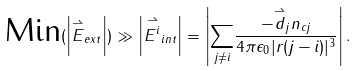<formula> <loc_0><loc_0><loc_500><loc_500>\text {Min} ( \left | { \overset { \rightharpoonup } { E } _ { e x t } } \right | ) \gg \left | { \overset { \rightharpoonup } { E ^ { i } } _ { i n t } } \right | = \left | { \underset { j \neq i } { \sum } \frac { - \overset { \rightharpoonup } { d } _ { j } n _ { c j } } { 4 \pi \epsilon _ { 0 } | r ( j - i ) | ^ { 3 } } } \right | .</formula> 